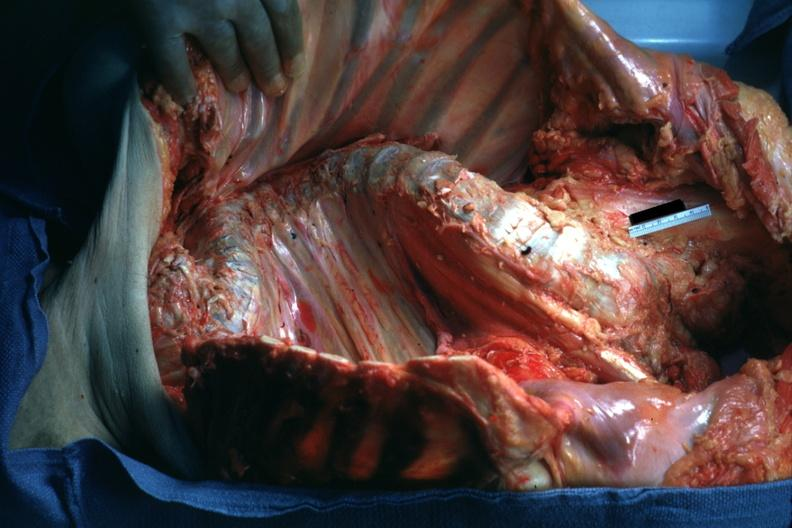what does this image show?
Answer the question using a single word or phrase. Opened body with organs 